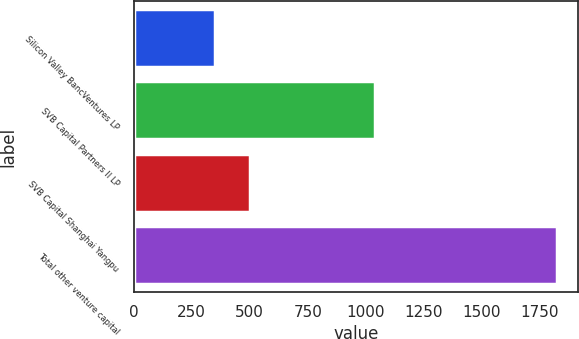Convert chart. <chart><loc_0><loc_0><loc_500><loc_500><bar_chart><fcel>Silicon Valley BancVentures LP<fcel>SVB Capital Partners II LP<fcel>SVB Capital Shanghai Yangpu<fcel>Total other venture capital<nl><fcel>352<fcel>1040<fcel>499.1<fcel>1823<nl></chart> 